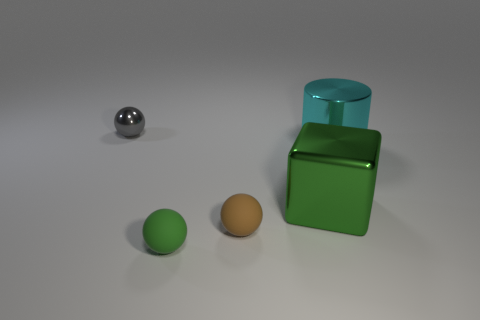Add 4 cyan metal cylinders. How many objects exist? 9 Subtract all cylinders. How many objects are left? 4 Subtract 0 purple cubes. How many objects are left? 5 Subtract all big metal objects. Subtract all green shiny blocks. How many objects are left? 2 Add 4 large cyan metal things. How many large cyan metal things are left? 5 Add 4 cyan metallic objects. How many cyan metallic objects exist? 5 